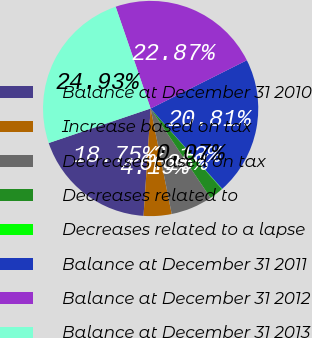Convert chart. <chart><loc_0><loc_0><loc_500><loc_500><pie_chart><fcel>Balance at December 31 2010<fcel>Increase based on tax<fcel>Decreases based on tax<fcel>Decreases related to<fcel>Decreases related to a lapse<fcel>Balance at December 31 2011<fcel>Balance at December 31 2012<fcel>Balance at December 31 2013<nl><fcel>18.75%<fcel>4.19%<fcel>6.25%<fcel>2.13%<fcel>0.07%<fcel>20.81%<fcel>22.87%<fcel>24.93%<nl></chart> 